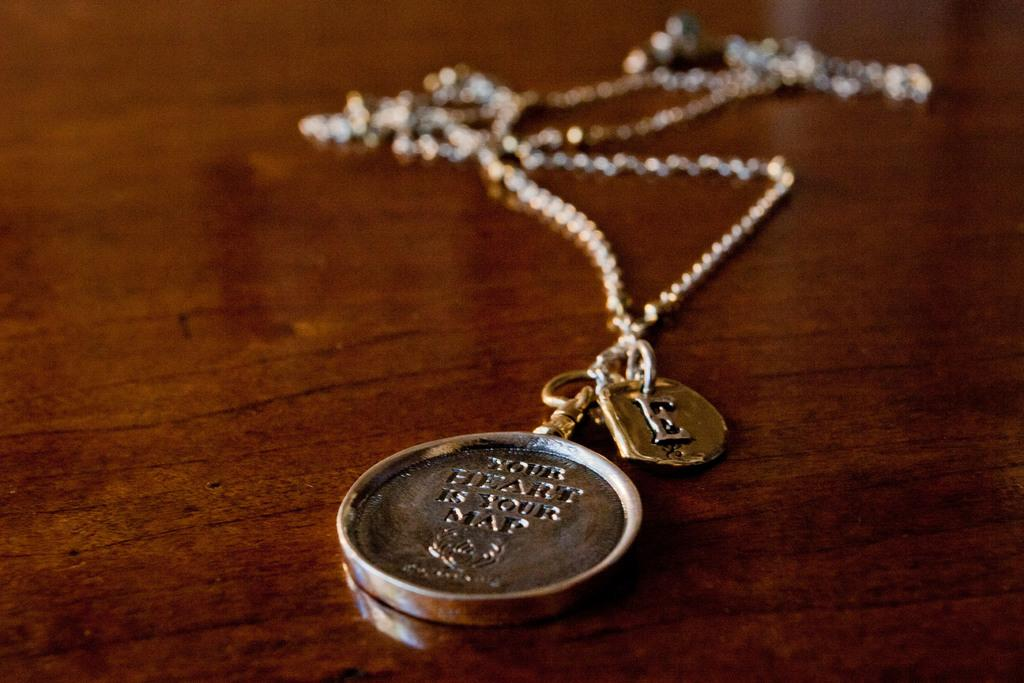<image>
Create a compact narrative representing the image presented. The necklace has a charm on it that says, “your heart is your map”. 